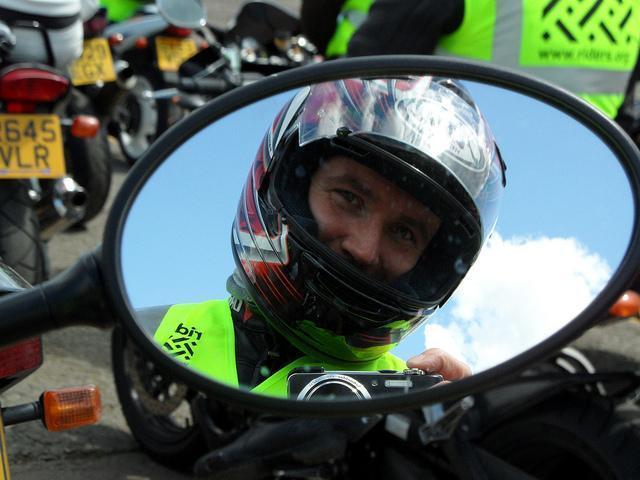How many motorcycles are there?
Give a very brief answer. 5. 